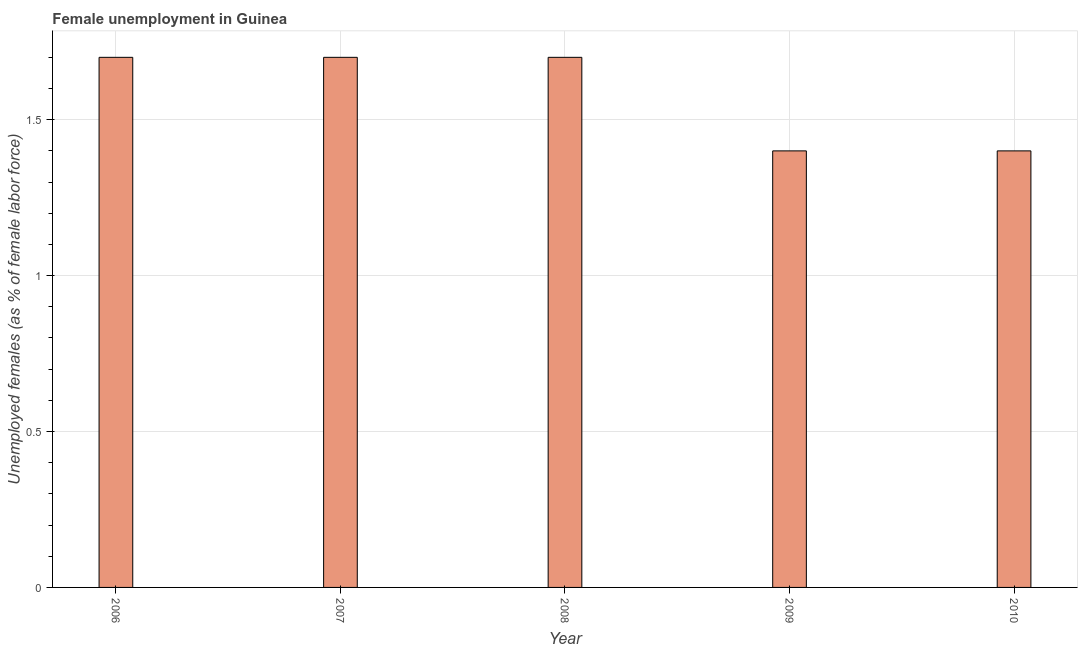Does the graph contain any zero values?
Offer a terse response. No. What is the title of the graph?
Provide a short and direct response. Female unemployment in Guinea. What is the label or title of the Y-axis?
Keep it short and to the point. Unemployed females (as % of female labor force). What is the unemployed females population in 2010?
Your response must be concise. 1.4. Across all years, what is the maximum unemployed females population?
Keep it short and to the point. 1.7. Across all years, what is the minimum unemployed females population?
Offer a terse response. 1.4. In which year was the unemployed females population maximum?
Provide a short and direct response. 2006. In which year was the unemployed females population minimum?
Your answer should be compact. 2009. What is the sum of the unemployed females population?
Offer a terse response. 7.9. What is the average unemployed females population per year?
Make the answer very short. 1.58. What is the median unemployed females population?
Give a very brief answer. 1.7. In how many years, is the unemployed females population greater than 1.4 %?
Offer a very short reply. 3. Do a majority of the years between 2008 and 2007 (inclusive) have unemployed females population greater than 0.7 %?
Ensure brevity in your answer.  No. What is the ratio of the unemployed females population in 2008 to that in 2009?
Provide a succinct answer. 1.21. Is the sum of the unemployed females population in 2007 and 2008 greater than the maximum unemployed females population across all years?
Offer a terse response. Yes. What is the difference between the highest and the lowest unemployed females population?
Keep it short and to the point. 0.3. In how many years, is the unemployed females population greater than the average unemployed females population taken over all years?
Make the answer very short. 3. How many bars are there?
Give a very brief answer. 5. Are all the bars in the graph horizontal?
Offer a terse response. No. Are the values on the major ticks of Y-axis written in scientific E-notation?
Keep it short and to the point. No. What is the Unemployed females (as % of female labor force) in 2006?
Your response must be concise. 1.7. What is the Unemployed females (as % of female labor force) of 2007?
Give a very brief answer. 1.7. What is the Unemployed females (as % of female labor force) of 2008?
Your answer should be very brief. 1.7. What is the Unemployed females (as % of female labor force) in 2009?
Provide a succinct answer. 1.4. What is the Unemployed females (as % of female labor force) in 2010?
Make the answer very short. 1.4. What is the difference between the Unemployed females (as % of female labor force) in 2006 and 2010?
Give a very brief answer. 0.3. What is the difference between the Unemployed females (as % of female labor force) in 2007 and 2008?
Ensure brevity in your answer.  0. What is the difference between the Unemployed females (as % of female labor force) in 2007 and 2010?
Offer a very short reply. 0.3. What is the ratio of the Unemployed females (as % of female labor force) in 2006 to that in 2007?
Make the answer very short. 1. What is the ratio of the Unemployed females (as % of female labor force) in 2006 to that in 2009?
Your response must be concise. 1.21. What is the ratio of the Unemployed females (as % of female labor force) in 2006 to that in 2010?
Give a very brief answer. 1.21. What is the ratio of the Unemployed females (as % of female labor force) in 2007 to that in 2009?
Offer a terse response. 1.21. What is the ratio of the Unemployed females (as % of female labor force) in 2007 to that in 2010?
Your answer should be compact. 1.21. What is the ratio of the Unemployed females (as % of female labor force) in 2008 to that in 2009?
Ensure brevity in your answer.  1.21. What is the ratio of the Unemployed females (as % of female labor force) in 2008 to that in 2010?
Provide a short and direct response. 1.21. 